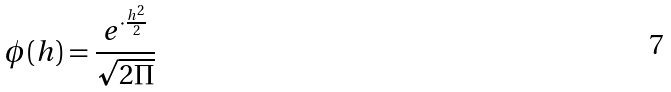<formula> <loc_0><loc_0><loc_500><loc_500>\phi ( h ) = \frac { e ^ { \cdot \frac { h ^ { 2 } } { 2 } } } { \sqrt { 2 \Pi } }</formula> 